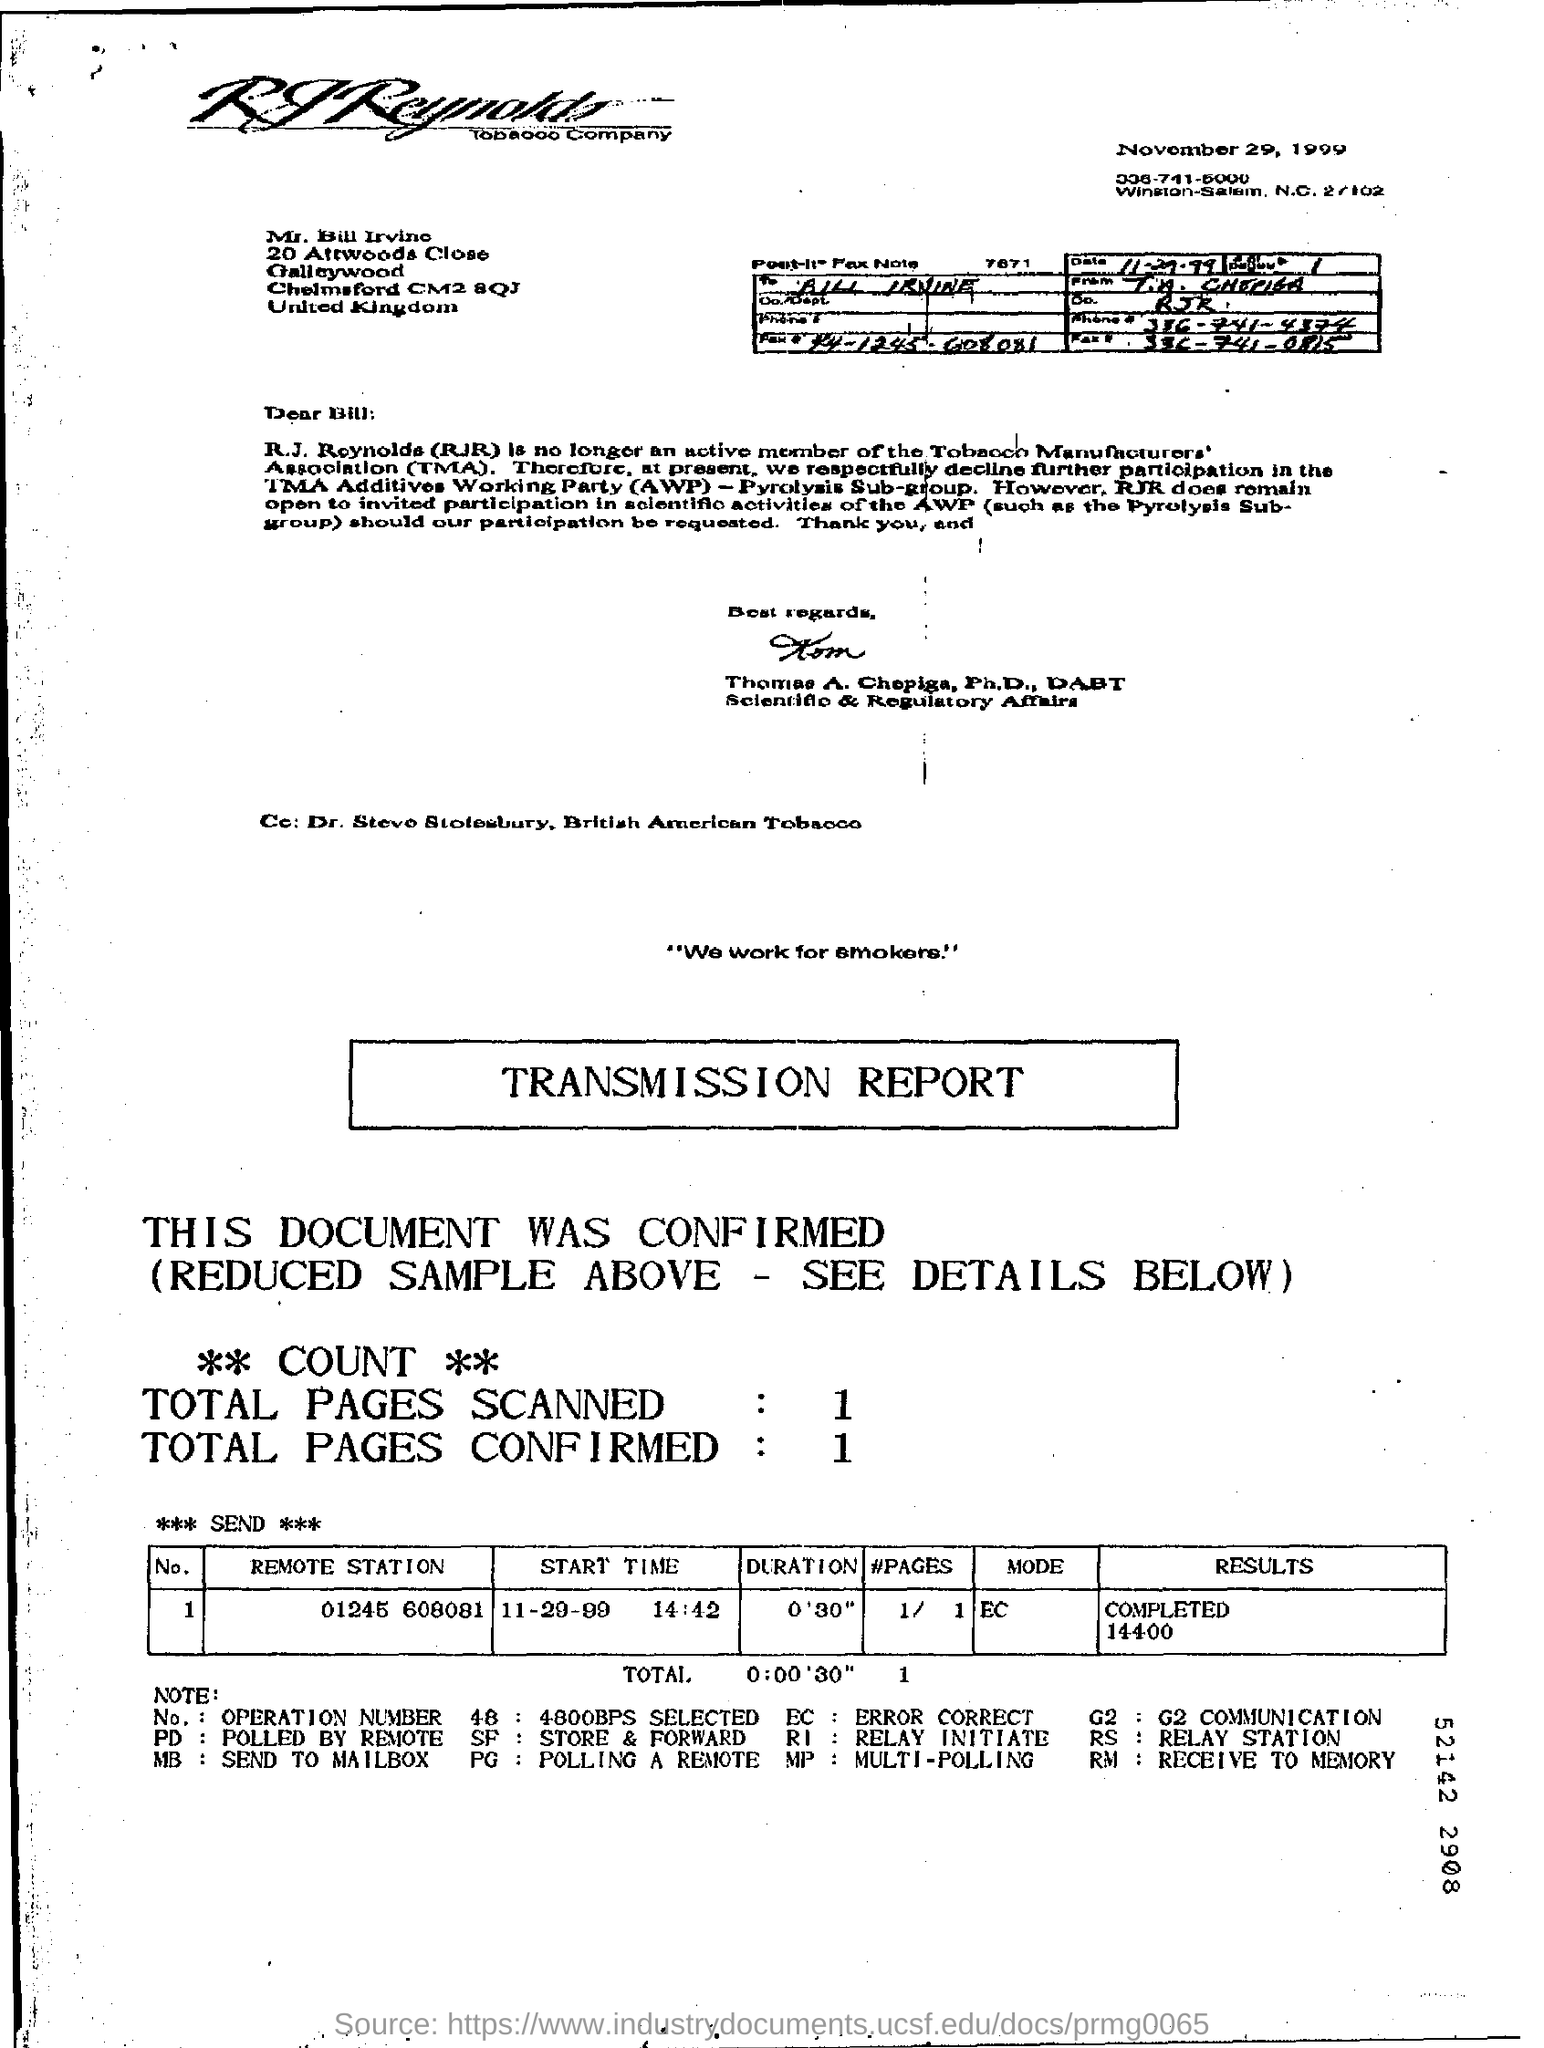Specify some key components in this picture. The start time mentioned in the transmission report is 14:42. The total number of pages confirmed is 1.. The total number of pages scanned is 1.. The mode mentioned in the transmission report is EC. 